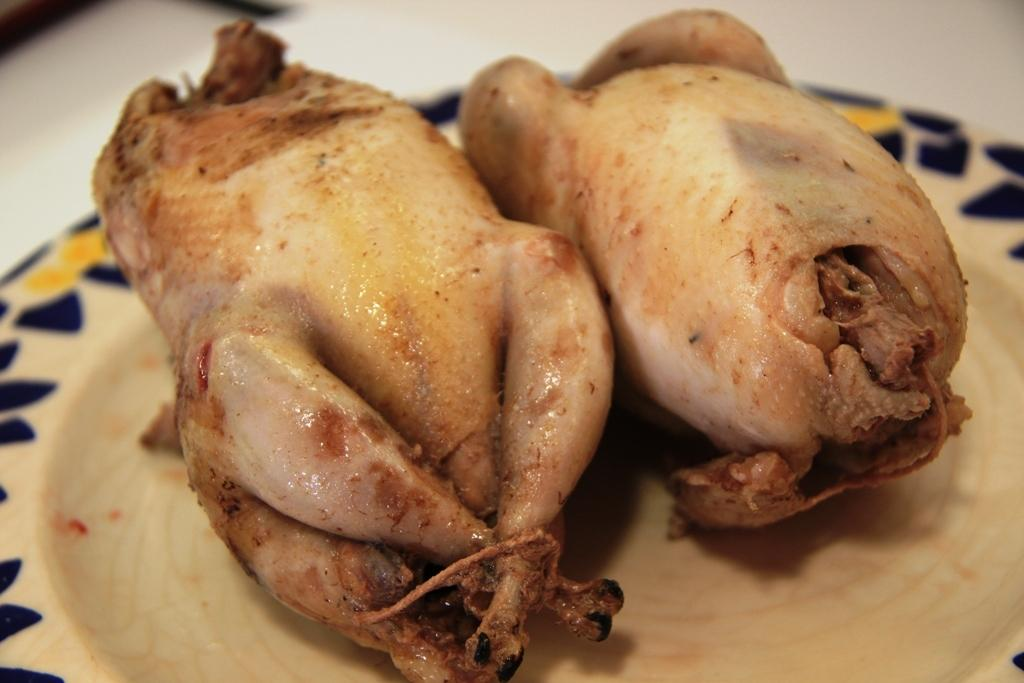What is present on the plate in the image? The food is on a plate in the image. What is the color of the surface the plate is on? The plate is on a white surface in the image. Who is the writer of the book on the plate in the image? There is no book on the plate in the image, and therefore no writer can be associated with it. 